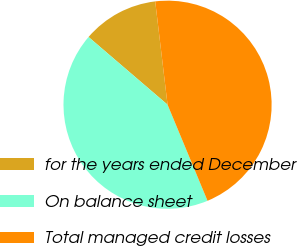Convert chart to OTSL. <chart><loc_0><loc_0><loc_500><loc_500><pie_chart><fcel>for the years ended December<fcel>On balance sheet<fcel>Total managed credit losses<nl><fcel>11.83%<fcel>42.55%<fcel>45.62%<nl></chart> 